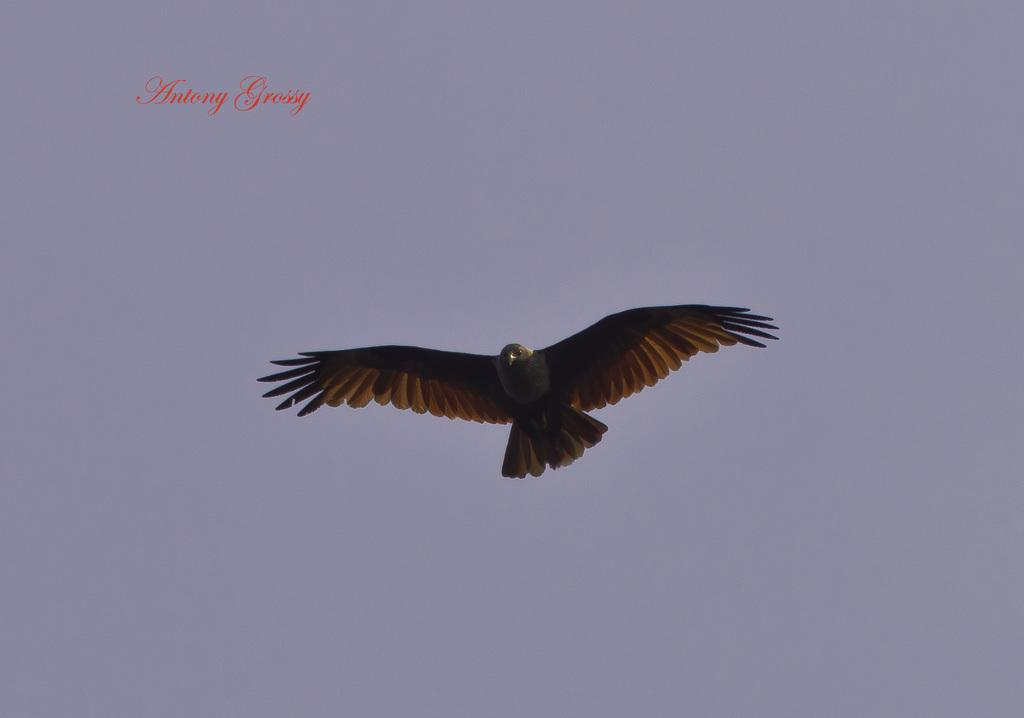What is the main subject of the image? The main subject of the image is a bird flying in the air. Where is the bird located in the image? The bird is in the middle of the image. What can be seen in the background of the image? There is a sky visible in the background of the image. How many worms can be seen crawling on the bird in the image? There are no worms present in the image; it features a bird flying in the air. What type of train is visible in the background of the image? There are no trains present in the image; it features a bird flying in the air with a sky visible in the background. 